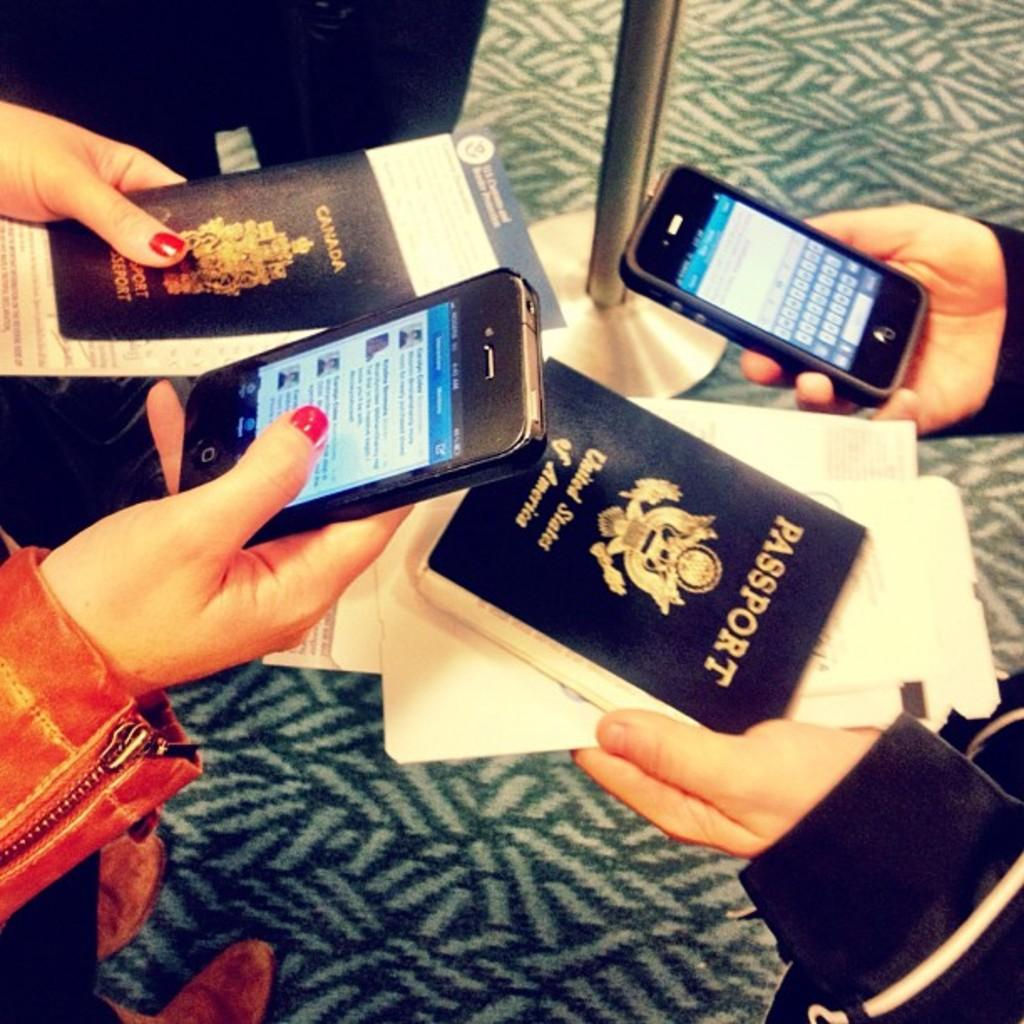<image>
Present a compact description of the photo's key features. Two people are looking at their phones and holding booklets that say Passport in gold letters. 